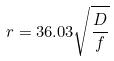<formula> <loc_0><loc_0><loc_500><loc_500>r = 3 6 . 0 3 \sqrt { \frac { D } { f } }</formula> 